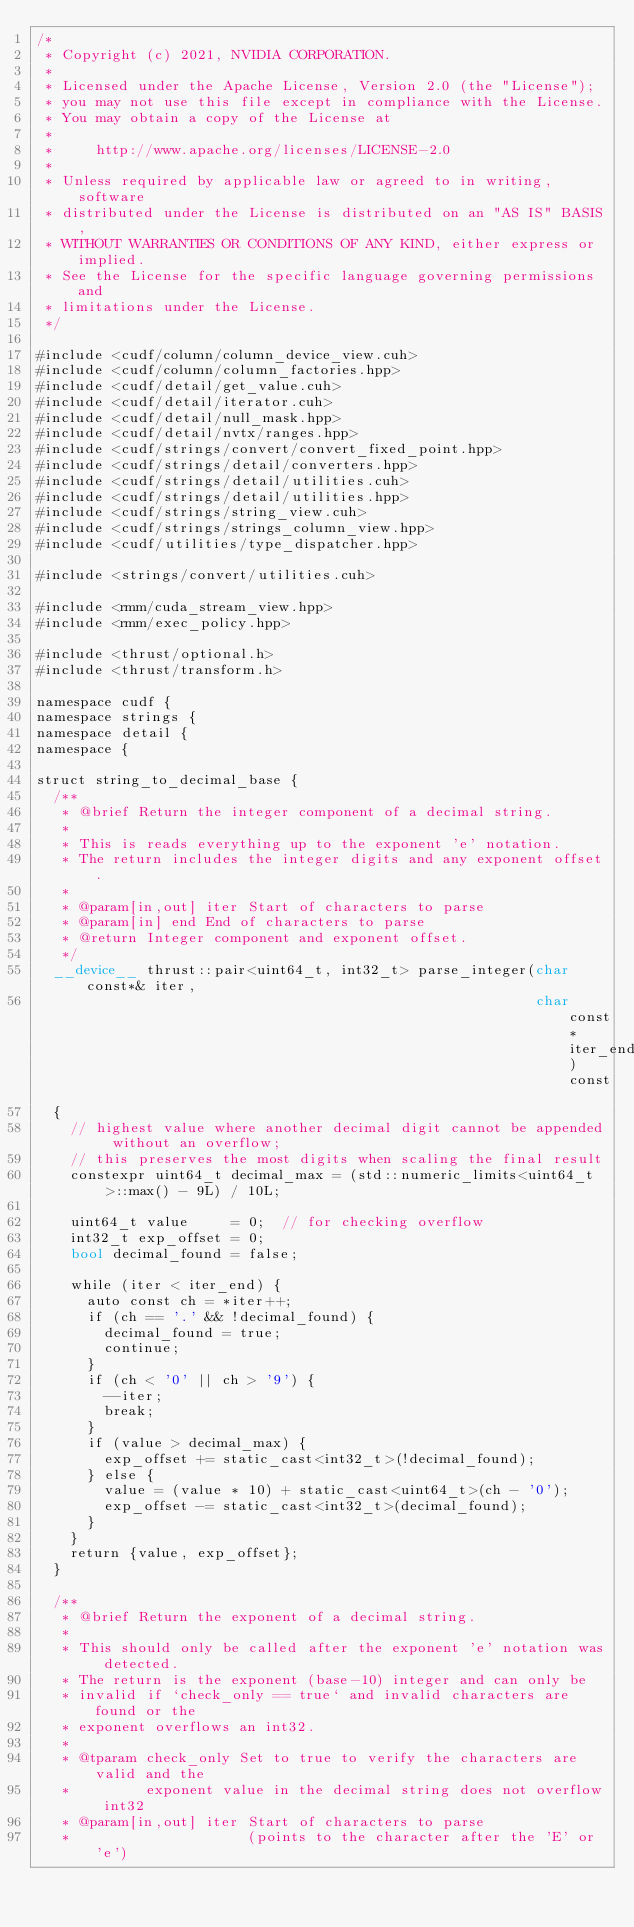Convert code to text. <code><loc_0><loc_0><loc_500><loc_500><_Cuda_>/*
 * Copyright (c) 2021, NVIDIA CORPORATION.
 *
 * Licensed under the Apache License, Version 2.0 (the "License");
 * you may not use this file except in compliance with the License.
 * You may obtain a copy of the License at
 *
 *     http://www.apache.org/licenses/LICENSE-2.0
 *
 * Unless required by applicable law or agreed to in writing, software
 * distributed under the License is distributed on an "AS IS" BASIS,
 * WITHOUT WARRANTIES OR CONDITIONS OF ANY KIND, either express or implied.
 * See the License for the specific language governing permissions and
 * limitations under the License.
 */

#include <cudf/column/column_device_view.cuh>
#include <cudf/column/column_factories.hpp>
#include <cudf/detail/get_value.cuh>
#include <cudf/detail/iterator.cuh>
#include <cudf/detail/null_mask.hpp>
#include <cudf/detail/nvtx/ranges.hpp>
#include <cudf/strings/convert/convert_fixed_point.hpp>
#include <cudf/strings/detail/converters.hpp>
#include <cudf/strings/detail/utilities.cuh>
#include <cudf/strings/detail/utilities.hpp>
#include <cudf/strings/string_view.cuh>
#include <cudf/strings/strings_column_view.hpp>
#include <cudf/utilities/type_dispatcher.hpp>

#include <strings/convert/utilities.cuh>

#include <rmm/cuda_stream_view.hpp>
#include <rmm/exec_policy.hpp>

#include <thrust/optional.h>
#include <thrust/transform.h>

namespace cudf {
namespace strings {
namespace detail {
namespace {

struct string_to_decimal_base {
  /**
   * @brief Return the integer component of a decimal string.
   *
   * This is reads everything up to the exponent 'e' notation.
   * The return includes the integer digits and any exponent offset.
   *
   * @param[in,out] iter Start of characters to parse
   * @param[in] end End of characters to parse
   * @return Integer component and exponent offset.
   */
  __device__ thrust::pair<uint64_t, int32_t> parse_integer(char const*& iter,
                                                           char const* iter_end) const
  {
    // highest value where another decimal digit cannot be appended without an overflow;
    // this preserves the most digits when scaling the final result
    constexpr uint64_t decimal_max = (std::numeric_limits<uint64_t>::max() - 9L) / 10L;

    uint64_t value     = 0;  // for checking overflow
    int32_t exp_offset = 0;
    bool decimal_found = false;

    while (iter < iter_end) {
      auto const ch = *iter++;
      if (ch == '.' && !decimal_found) {
        decimal_found = true;
        continue;
      }
      if (ch < '0' || ch > '9') {
        --iter;
        break;
      }
      if (value > decimal_max) {
        exp_offset += static_cast<int32_t>(!decimal_found);
      } else {
        value = (value * 10) + static_cast<uint64_t>(ch - '0');
        exp_offset -= static_cast<int32_t>(decimal_found);
      }
    }
    return {value, exp_offset};
  }

  /**
   * @brief Return the exponent of a decimal string.
   *
   * This should only be called after the exponent 'e' notation was detected.
   * The return is the exponent (base-10) integer and can only be
   * invalid if `check_only == true` and invalid characters are found or the
   * exponent overflows an int32.
   *
   * @tparam check_only Set to true to verify the characters are valid and the
   *         exponent value in the decimal string does not overflow int32
   * @param[in,out] iter Start of characters to parse
   *                     (points to the character after the 'E' or 'e')</code> 